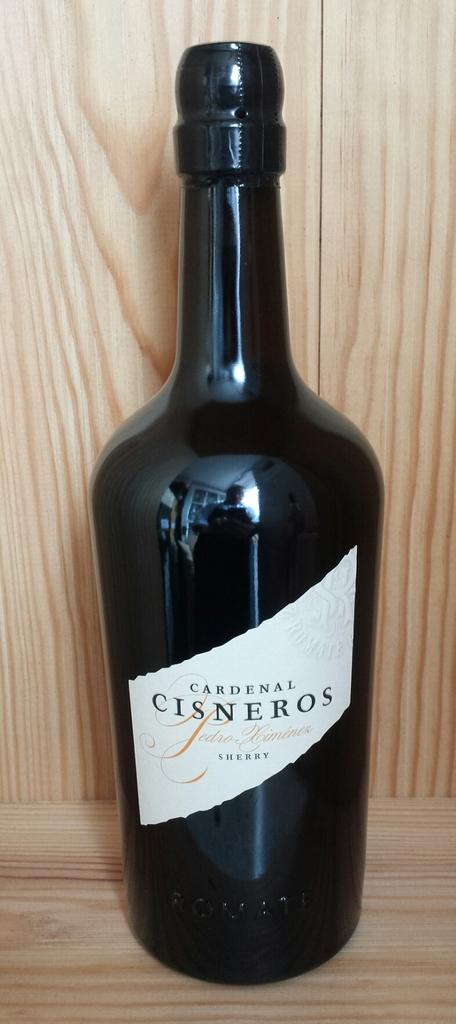<image>
Create a compact narrative representing the image presented. bottle of cardenal cisneros sherry on a wood shelf 